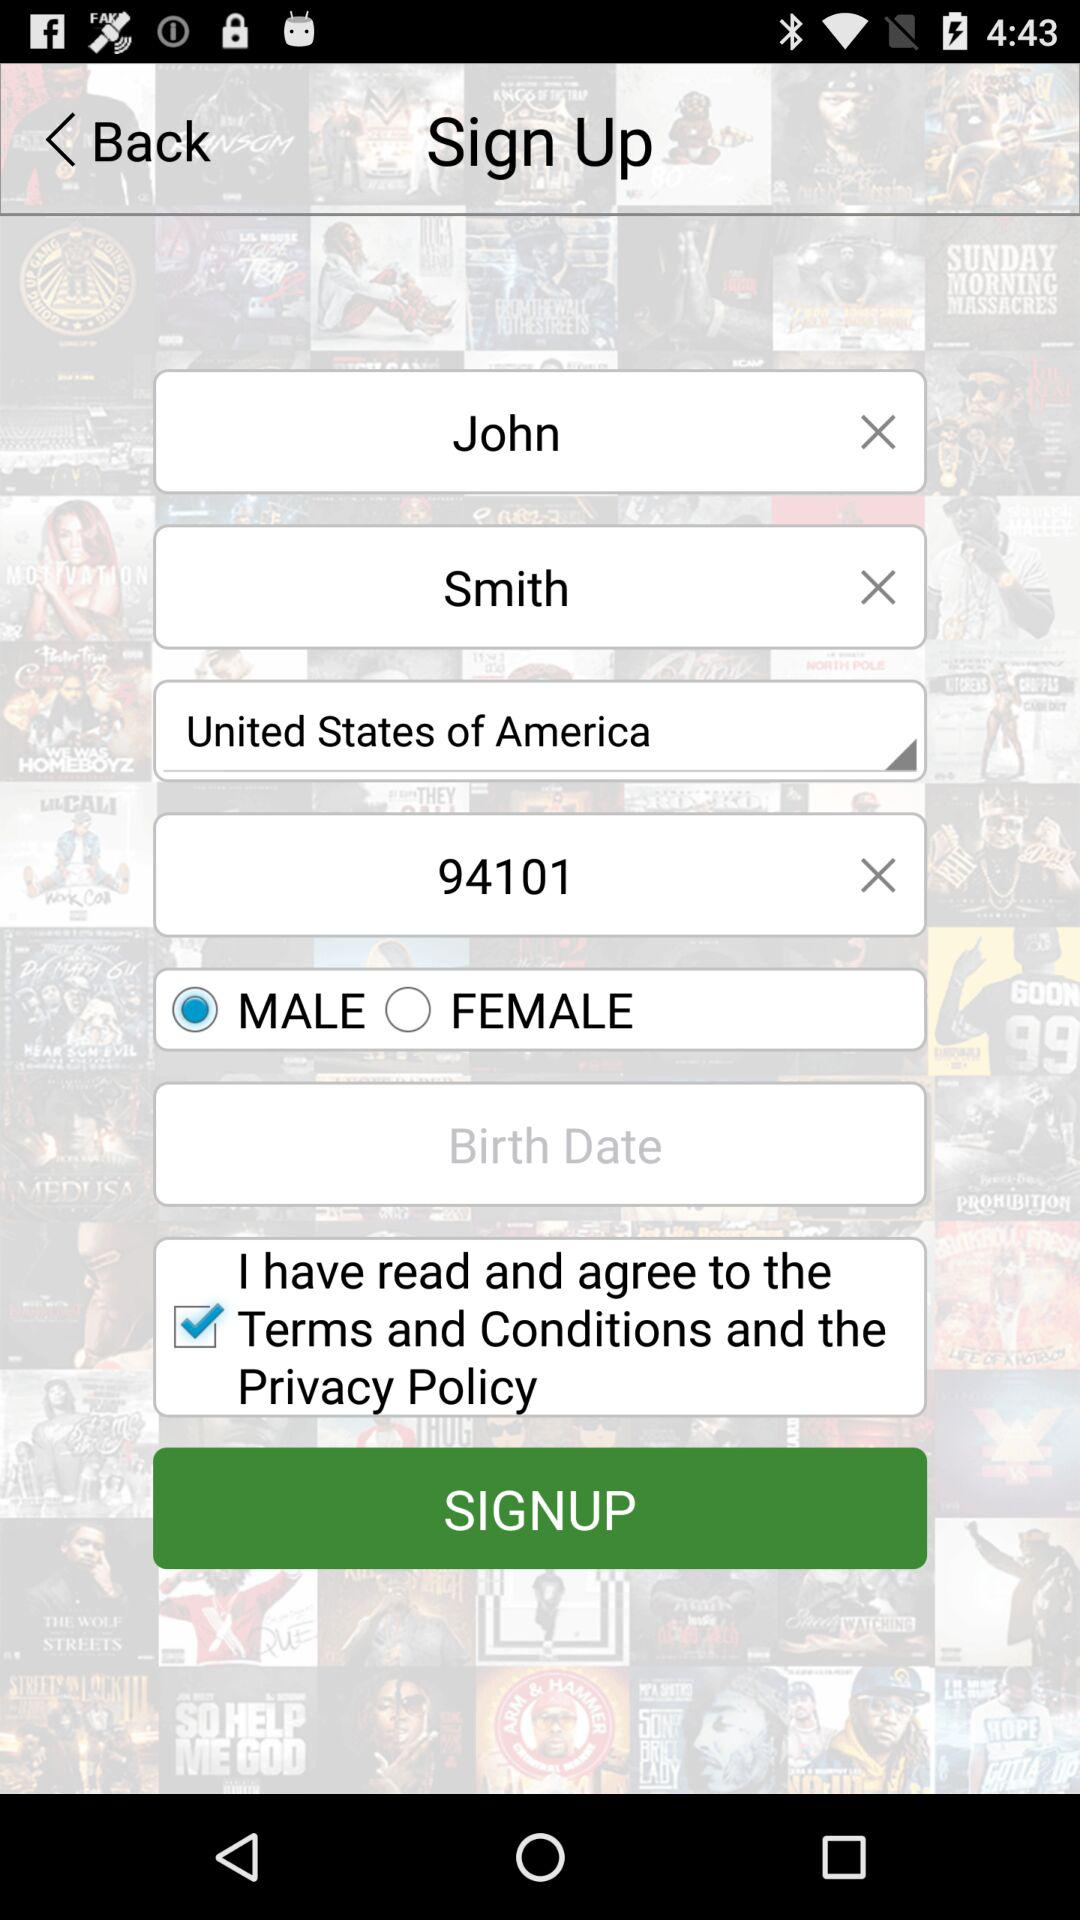What is the first name? The first name is John. 